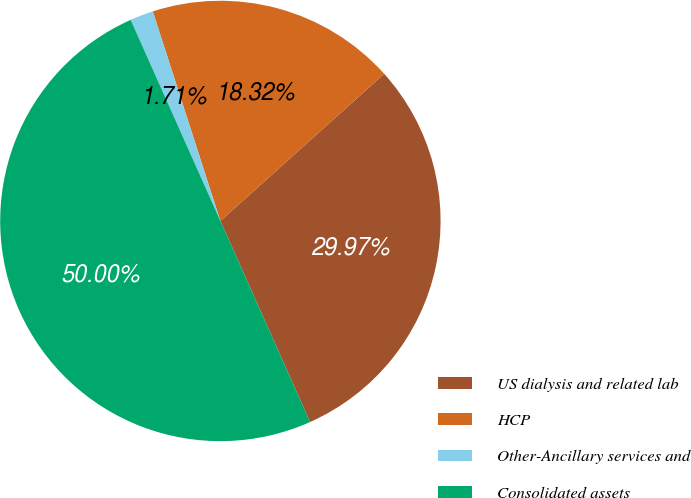<chart> <loc_0><loc_0><loc_500><loc_500><pie_chart><fcel>US dialysis and related lab<fcel>HCP<fcel>Other-Ancillary services and<fcel>Consolidated assets<nl><fcel>29.97%<fcel>18.32%<fcel>1.71%<fcel>50.0%<nl></chart> 